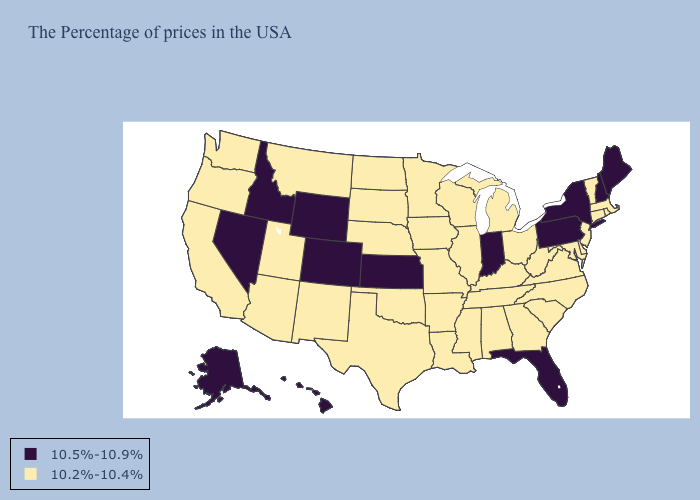Does the first symbol in the legend represent the smallest category?
Write a very short answer. No. Name the states that have a value in the range 10.2%-10.4%?
Answer briefly. Massachusetts, Rhode Island, Vermont, Connecticut, New Jersey, Delaware, Maryland, Virginia, North Carolina, South Carolina, West Virginia, Ohio, Georgia, Michigan, Kentucky, Alabama, Tennessee, Wisconsin, Illinois, Mississippi, Louisiana, Missouri, Arkansas, Minnesota, Iowa, Nebraska, Oklahoma, Texas, South Dakota, North Dakota, New Mexico, Utah, Montana, Arizona, California, Washington, Oregon. What is the value of Illinois?
Short answer required. 10.2%-10.4%. Does Nevada have the lowest value in the West?
Concise answer only. No. What is the lowest value in the USA?
Write a very short answer. 10.2%-10.4%. Name the states that have a value in the range 10.5%-10.9%?
Be succinct. Maine, New Hampshire, New York, Pennsylvania, Florida, Indiana, Kansas, Wyoming, Colorado, Idaho, Nevada, Alaska, Hawaii. What is the value of New York?
Short answer required. 10.5%-10.9%. Among the states that border Maine , which have the highest value?
Keep it brief. New Hampshire. Name the states that have a value in the range 10.5%-10.9%?
Short answer required. Maine, New Hampshire, New York, Pennsylvania, Florida, Indiana, Kansas, Wyoming, Colorado, Idaho, Nevada, Alaska, Hawaii. Name the states that have a value in the range 10.5%-10.9%?
Short answer required. Maine, New Hampshire, New York, Pennsylvania, Florida, Indiana, Kansas, Wyoming, Colorado, Idaho, Nevada, Alaska, Hawaii. Name the states that have a value in the range 10.5%-10.9%?
Short answer required. Maine, New Hampshire, New York, Pennsylvania, Florida, Indiana, Kansas, Wyoming, Colorado, Idaho, Nevada, Alaska, Hawaii. What is the value of Louisiana?
Write a very short answer. 10.2%-10.4%. Which states have the lowest value in the USA?
Write a very short answer. Massachusetts, Rhode Island, Vermont, Connecticut, New Jersey, Delaware, Maryland, Virginia, North Carolina, South Carolina, West Virginia, Ohio, Georgia, Michigan, Kentucky, Alabama, Tennessee, Wisconsin, Illinois, Mississippi, Louisiana, Missouri, Arkansas, Minnesota, Iowa, Nebraska, Oklahoma, Texas, South Dakota, North Dakota, New Mexico, Utah, Montana, Arizona, California, Washington, Oregon. Name the states that have a value in the range 10.5%-10.9%?
Short answer required. Maine, New Hampshire, New York, Pennsylvania, Florida, Indiana, Kansas, Wyoming, Colorado, Idaho, Nevada, Alaska, Hawaii. What is the value of South Dakota?
Be succinct. 10.2%-10.4%. 